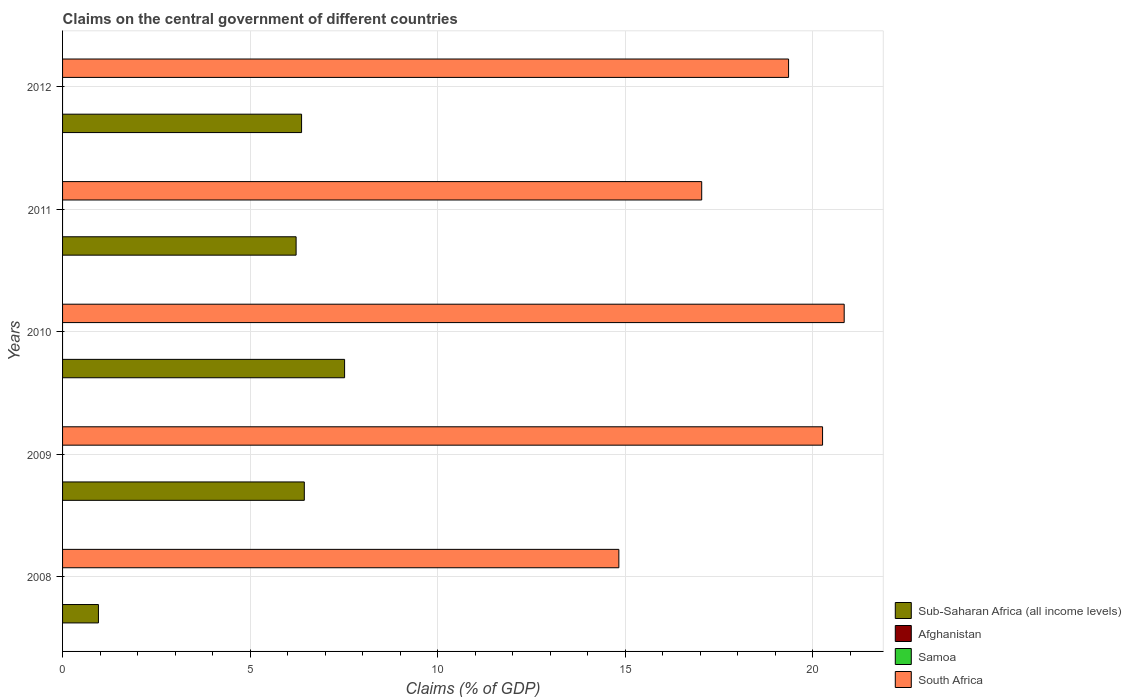How many different coloured bars are there?
Offer a terse response. 2. Are the number of bars per tick equal to the number of legend labels?
Give a very brief answer. No. Are the number of bars on each tick of the Y-axis equal?
Your answer should be very brief. Yes. How many bars are there on the 1st tick from the top?
Make the answer very short. 2. How many bars are there on the 2nd tick from the bottom?
Offer a terse response. 2. What is the label of the 2nd group of bars from the top?
Offer a terse response. 2011. In how many cases, is the number of bars for a given year not equal to the number of legend labels?
Offer a terse response. 5. Across all years, what is the maximum percentage of GDP claimed on the central government in South Africa?
Provide a short and direct response. 20.84. Across all years, what is the minimum percentage of GDP claimed on the central government in Samoa?
Provide a short and direct response. 0. What is the total percentage of GDP claimed on the central government in South Africa in the graph?
Make the answer very short. 92.35. What is the difference between the percentage of GDP claimed on the central government in Sub-Saharan Africa (all income levels) in 2009 and that in 2011?
Your answer should be very brief. 0.22. What is the difference between the percentage of GDP claimed on the central government in Samoa in 2010 and the percentage of GDP claimed on the central government in Sub-Saharan Africa (all income levels) in 2012?
Your response must be concise. -6.37. In the year 2008, what is the difference between the percentage of GDP claimed on the central government in South Africa and percentage of GDP claimed on the central government in Sub-Saharan Africa (all income levels)?
Your response must be concise. 13.88. What is the ratio of the percentage of GDP claimed on the central government in South Africa in 2011 to that in 2012?
Your response must be concise. 0.88. Is the difference between the percentage of GDP claimed on the central government in South Africa in 2011 and 2012 greater than the difference between the percentage of GDP claimed on the central government in Sub-Saharan Africa (all income levels) in 2011 and 2012?
Ensure brevity in your answer.  No. What is the difference between the highest and the second highest percentage of GDP claimed on the central government in South Africa?
Offer a very short reply. 0.58. What is the difference between the highest and the lowest percentage of GDP claimed on the central government in South Africa?
Your answer should be very brief. 6.01. Is the sum of the percentage of GDP claimed on the central government in Sub-Saharan Africa (all income levels) in 2009 and 2012 greater than the maximum percentage of GDP claimed on the central government in Samoa across all years?
Your answer should be compact. Yes. Is it the case that in every year, the sum of the percentage of GDP claimed on the central government in Samoa and percentage of GDP claimed on the central government in Sub-Saharan Africa (all income levels) is greater than the sum of percentage of GDP claimed on the central government in South Africa and percentage of GDP claimed on the central government in Afghanistan?
Offer a very short reply. No. Is it the case that in every year, the sum of the percentage of GDP claimed on the central government in Afghanistan and percentage of GDP claimed on the central government in Samoa is greater than the percentage of GDP claimed on the central government in South Africa?
Provide a succinct answer. No. How many bars are there?
Offer a terse response. 10. Are all the bars in the graph horizontal?
Offer a very short reply. Yes. How many years are there in the graph?
Provide a short and direct response. 5. What is the difference between two consecutive major ticks on the X-axis?
Your answer should be compact. 5. Are the values on the major ticks of X-axis written in scientific E-notation?
Offer a terse response. No. Does the graph contain any zero values?
Keep it short and to the point. Yes. Does the graph contain grids?
Your answer should be compact. Yes. What is the title of the graph?
Make the answer very short. Claims on the central government of different countries. Does "Jordan" appear as one of the legend labels in the graph?
Give a very brief answer. No. What is the label or title of the X-axis?
Offer a very short reply. Claims (% of GDP). What is the label or title of the Y-axis?
Make the answer very short. Years. What is the Claims (% of GDP) in Sub-Saharan Africa (all income levels) in 2008?
Provide a short and direct response. 0.96. What is the Claims (% of GDP) in Afghanistan in 2008?
Provide a short and direct response. 0. What is the Claims (% of GDP) in Samoa in 2008?
Provide a short and direct response. 0. What is the Claims (% of GDP) in South Africa in 2008?
Keep it short and to the point. 14.84. What is the Claims (% of GDP) in Sub-Saharan Africa (all income levels) in 2009?
Give a very brief answer. 6.45. What is the Claims (% of GDP) of South Africa in 2009?
Provide a short and direct response. 20.27. What is the Claims (% of GDP) in Sub-Saharan Africa (all income levels) in 2010?
Offer a terse response. 7.52. What is the Claims (% of GDP) of Samoa in 2010?
Your answer should be very brief. 0. What is the Claims (% of GDP) in South Africa in 2010?
Offer a terse response. 20.84. What is the Claims (% of GDP) in Sub-Saharan Africa (all income levels) in 2011?
Provide a short and direct response. 6.23. What is the Claims (% of GDP) in Afghanistan in 2011?
Provide a succinct answer. 0. What is the Claims (% of GDP) of Samoa in 2011?
Provide a short and direct response. 0. What is the Claims (% of GDP) of South Africa in 2011?
Provide a succinct answer. 17.04. What is the Claims (% of GDP) in Sub-Saharan Africa (all income levels) in 2012?
Provide a succinct answer. 6.37. What is the Claims (% of GDP) of South Africa in 2012?
Provide a succinct answer. 19.36. Across all years, what is the maximum Claims (% of GDP) in Sub-Saharan Africa (all income levels)?
Provide a succinct answer. 7.52. Across all years, what is the maximum Claims (% of GDP) of South Africa?
Your answer should be very brief. 20.84. Across all years, what is the minimum Claims (% of GDP) of Sub-Saharan Africa (all income levels)?
Give a very brief answer. 0.96. Across all years, what is the minimum Claims (% of GDP) in South Africa?
Keep it short and to the point. 14.84. What is the total Claims (% of GDP) of Sub-Saharan Africa (all income levels) in the graph?
Provide a short and direct response. 27.53. What is the total Claims (% of GDP) of Afghanistan in the graph?
Ensure brevity in your answer.  0. What is the total Claims (% of GDP) of Samoa in the graph?
Offer a very short reply. 0. What is the total Claims (% of GDP) of South Africa in the graph?
Make the answer very short. 92.35. What is the difference between the Claims (% of GDP) in Sub-Saharan Africa (all income levels) in 2008 and that in 2009?
Offer a very short reply. -5.49. What is the difference between the Claims (% of GDP) in South Africa in 2008 and that in 2009?
Provide a succinct answer. -5.43. What is the difference between the Claims (% of GDP) of Sub-Saharan Africa (all income levels) in 2008 and that in 2010?
Offer a terse response. -6.56. What is the difference between the Claims (% of GDP) of South Africa in 2008 and that in 2010?
Provide a short and direct response. -6.01. What is the difference between the Claims (% of GDP) in Sub-Saharan Africa (all income levels) in 2008 and that in 2011?
Your answer should be very brief. -5.27. What is the difference between the Claims (% of GDP) of South Africa in 2008 and that in 2011?
Ensure brevity in your answer.  -2.21. What is the difference between the Claims (% of GDP) in Sub-Saharan Africa (all income levels) in 2008 and that in 2012?
Make the answer very short. -5.42. What is the difference between the Claims (% of GDP) of South Africa in 2008 and that in 2012?
Offer a terse response. -4.53. What is the difference between the Claims (% of GDP) in Sub-Saharan Africa (all income levels) in 2009 and that in 2010?
Offer a very short reply. -1.07. What is the difference between the Claims (% of GDP) in South Africa in 2009 and that in 2010?
Make the answer very short. -0.58. What is the difference between the Claims (% of GDP) of Sub-Saharan Africa (all income levels) in 2009 and that in 2011?
Your response must be concise. 0.22. What is the difference between the Claims (% of GDP) of South Africa in 2009 and that in 2011?
Your answer should be very brief. 3.22. What is the difference between the Claims (% of GDP) of Sub-Saharan Africa (all income levels) in 2009 and that in 2012?
Your response must be concise. 0.07. What is the difference between the Claims (% of GDP) of South Africa in 2009 and that in 2012?
Ensure brevity in your answer.  0.91. What is the difference between the Claims (% of GDP) in Sub-Saharan Africa (all income levels) in 2010 and that in 2011?
Provide a succinct answer. 1.29. What is the difference between the Claims (% of GDP) in South Africa in 2010 and that in 2011?
Give a very brief answer. 3.8. What is the difference between the Claims (% of GDP) in Sub-Saharan Africa (all income levels) in 2010 and that in 2012?
Give a very brief answer. 1.15. What is the difference between the Claims (% of GDP) of South Africa in 2010 and that in 2012?
Offer a terse response. 1.48. What is the difference between the Claims (% of GDP) in Sub-Saharan Africa (all income levels) in 2011 and that in 2012?
Your answer should be very brief. -0.15. What is the difference between the Claims (% of GDP) in South Africa in 2011 and that in 2012?
Ensure brevity in your answer.  -2.32. What is the difference between the Claims (% of GDP) of Sub-Saharan Africa (all income levels) in 2008 and the Claims (% of GDP) of South Africa in 2009?
Your response must be concise. -19.31. What is the difference between the Claims (% of GDP) of Sub-Saharan Africa (all income levels) in 2008 and the Claims (% of GDP) of South Africa in 2010?
Make the answer very short. -19.89. What is the difference between the Claims (% of GDP) of Sub-Saharan Africa (all income levels) in 2008 and the Claims (% of GDP) of South Africa in 2011?
Give a very brief answer. -16.09. What is the difference between the Claims (% of GDP) in Sub-Saharan Africa (all income levels) in 2008 and the Claims (% of GDP) in South Africa in 2012?
Keep it short and to the point. -18.4. What is the difference between the Claims (% of GDP) in Sub-Saharan Africa (all income levels) in 2009 and the Claims (% of GDP) in South Africa in 2010?
Your response must be concise. -14.4. What is the difference between the Claims (% of GDP) in Sub-Saharan Africa (all income levels) in 2009 and the Claims (% of GDP) in South Africa in 2011?
Your answer should be compact. -10.6. What is the difference between the Claims (% of GDP) of Sub-Saharan Africa (all income levels) in 2009 and the Claims (% of GDP) of South Africa in 2012?
Ensure brevity in your answer.  -12.91. What is the difference between the Claims (% of GDP) of Sub-Saharan Africa (all income levels) in 2010 and the Claims (% of GDP) of South Africa in 2011?
Your response must be concise. -9.52. What is the difference between the Claims (% of GDP) of Sub-Saharan Africa (all income levels) in 2010 and the Claims (% of GDP) of South Africa in 2012?
Your answer should be compact. -11.84. What is the difference between the Claims (% of GDP) in Sub-Saharan Africa (all income levels) in 2011 and the Claims (% of GDP) in South Africa in 2012?
Offer a terse response. -13.13. What is the average Claims (% of GDP) in Sub-Saharan Africa (all income levels) per year?
Your response must be concise. 5.51. What is the average Claims (% of GDP) in Samoa per year?
Your answer should be very brief. 0. What is the average Claims (% of GDP) of South Africa per year?
Your response must be concise. 18.47. In the year 2008, what is the difference between the Claims (% of GDP) in Sub-Saharan Africa (all income levels) and Claims (% of GDP) in South Africa?
Ensure brevity in your answer.  -13.88. In the year 2009, what is the difference between the Claims (% of GDP) in Sub-Saharan Africa (all income levels) and Claims (% of GDP) in South Africa?
Offer a terse response. -13.82. In the year 2010, what is the difference between the Claims (% of GDP) of Sub-Saharan Africa (all income levels) and Claims (% of GDP) of South Africa?
Provide a succinct answer. -13.32. In the year 2011, what is the difference between the Claims (% of GDP) of Sub-Saharan Africa (all income levels) and Claims (% of GDP) of South Africa?
Provide a short and direct response. -10.82. In the year 2012, what is the difference between the Claims (% of GDP) of Sub-Saharan Africa (all income levels) and Claims (% of GDP) of South Africa?
Give a very brief answer. -12.99. What is the ratio of the Claims (% of GDP) of Sub-Saharan Africa (all income levels) in 2008 to that in 2009?
Provide a succinct answer. 0.15. What is the ratio of the Claims (% of GDP) of South Africa in 2008 to that in 2009?
Give a very brief answer. 0.73. What is the ratio of the Claims (% of GDP) of Sub-Saharan Africa (all income levels) in 2008 to that in 2010?
Give a very brief answer. 0.13. What is the ratio of the Claims (% of GDP) in South Africa in 2008 to that in 2010?
Ensure brevity in your answer.  0.71. What is the ratio of the Claims (% of GDP) of Sub-Saharan Africa (all income levels) in 2008 to that in 2011?
Offer a terse response. 0.15. What is the ratio of the Claims (% of GDP) in South Africa in 2008 to that in 2011?
Make the answer very short. 0.87. What is the ratio of the Claims (% of GDP) of Sub-Saharan Africa (all income levels) in 2008 to that in 2012?
Keep it short and to the point. 0.15. What is the ratio of the Claims (% of GDP) of South Africa in 2008 to that in 2012?
Your answer should be compact. 0.77. What is the ratio of the Claims (% of GDP) of South Africa in 2009 to that in 2010?
Your response must be concise. 0.97. What is the ratio of the Claims (% of GDP) of Sub-Saharan Africa (all income levels) in 2009 to that in 2011?
Offer a terse response. 1.04. What is the ratio of the Claims (% of GDP) in South Africa in 2009 to that in 2011?
Give a very brief answer. 1.19. What is the ratio of the Claims (% of GDP) in Sub-Saharan Africa (all income levels) in 2009 to that in 2012?
Provide a short and direct response. 1.01. What is the ratio of the Claims (% of GDP) in South Africa in 2009 to that in 2012?
Give a very brief answer. 1.05. What is the ratio of the Claims (% of GDP) of Sub-Saharan Africa (all income levels) in 2010 to that in 2011?
Make the answer very short. 1.21. What is the ratio of the Claims (% of GDP) of South Africa in 2010 to that in 2011?
Give a very brief answer. 1.22. What is the ratio of the Claims (% of GDP) in Sub-Saharan Africa (all income levels) in 2010 to that in 2012?
Offer a very short reply. 1.18. What is the ratio of the Claims (% of GDP) in South Africa in 2010 to that in 2012?
Offer a very short reply. 1.08. What is the ratio of the Claims (% of GDP) in Sub-Saharan Africa (all income levels) in 2011 to that in 2012?
Make the answer very short. 0.98. What is the ratio of the Claims (% of GDP) in South Africa in 2011 to that in 2012?
Offer a very short reply. 0.88. What is the difference between the highest and the second highest Claims (% of GDP) in Sub-Saharan Africa (all income levels)?
Ensure brevity in your answer.  1.07. What is the difference between the highest and the second highest Claims (% of GDP) in South Africa?
Give a very brief answer. 0.58. What is the difference between the highest and the lowest Claims (% of GDP) of Sub-Saharan Africa (all income levels)?
Provide a succinct answer. 6.56. What is the difference between the highest and the lowest Claims (% of GDP) in South Africa?
Ensure brevity in your answer.  6.01. 